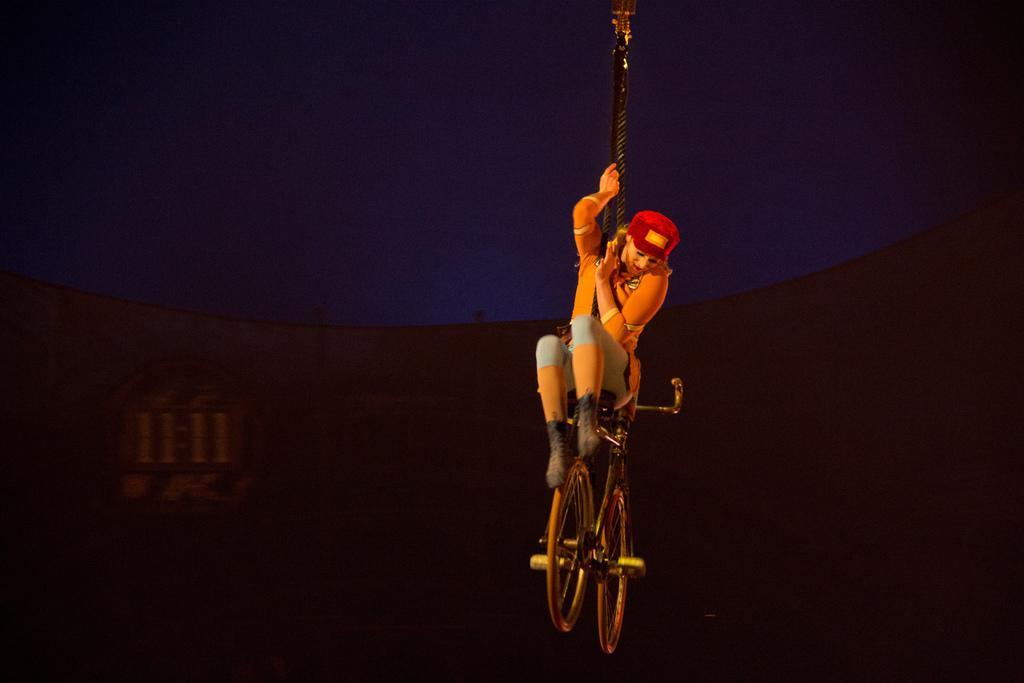Can you describe this image briefly? In this image we can see a woman in the sky sitting on a cycle holding a rope. 